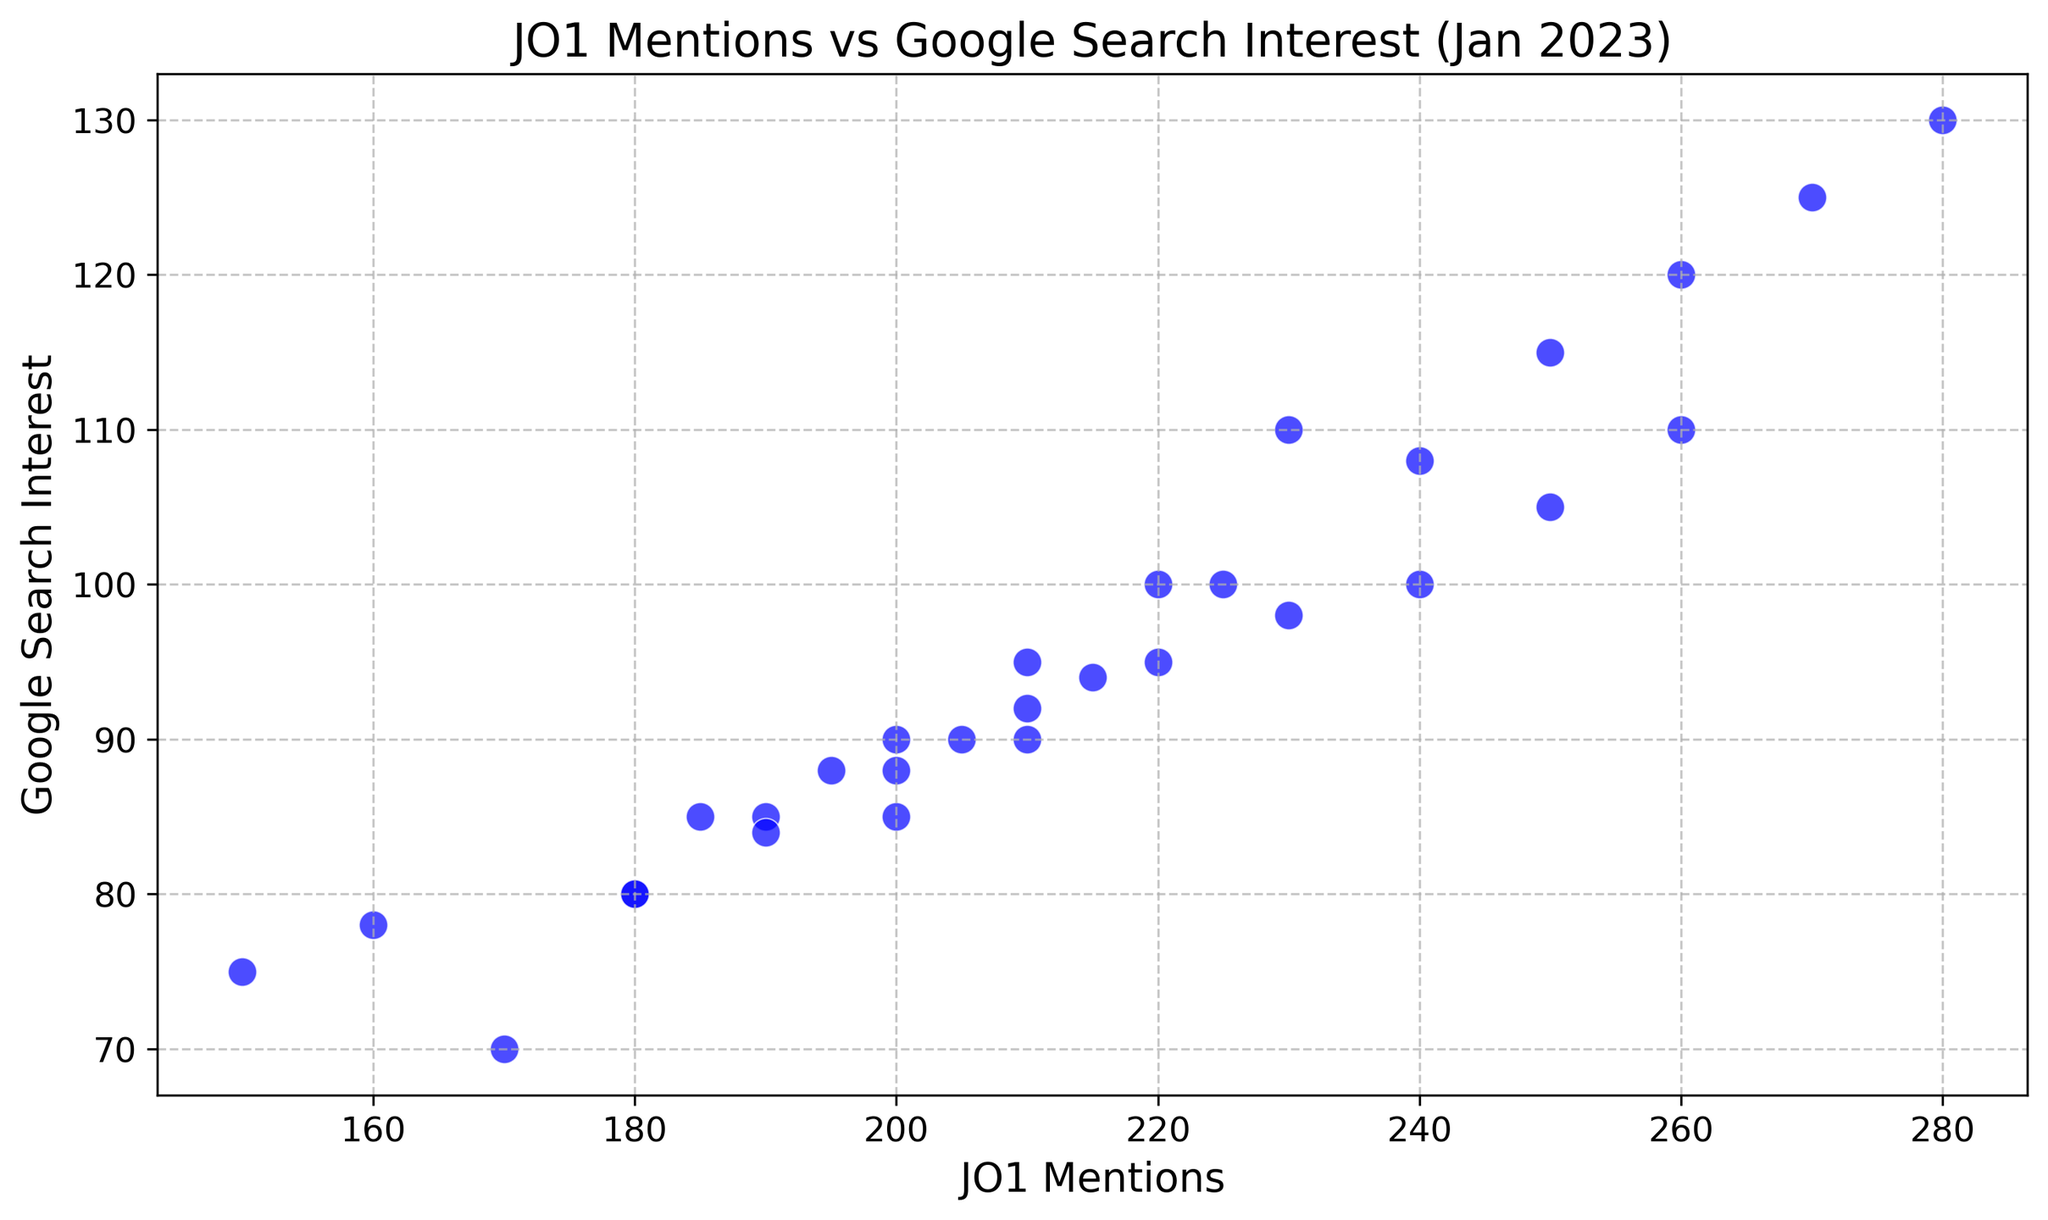Which point represents the maximum JO1 mentions, and what is the corresponding Google search interest? Identify the highest value on the x-axis (JO1 mentions); it's around 280. Trace this point up to the scatter point, which correlates to 130 on the y-axis (Google search interest).
Answer: 280 mentions, 130 interest On what date were JO1 mentions and Google search interest both at their highest? Referring to the maximum values identified in the previous question, find the corresponding date in the data; January 15th has 280 mentions and 130 interest.
Answer: January 15th What is the difference between the highest and lowest Google search interest? Identify the highest value of Google search interest (130) and the lowest (70). Subtract the lowest from the highest: 130 - 70.
Answer: 60 What is the average JO1 mentions for days when the Google search interest is 100 or above? Sum the JO1 mentions for dates when Google search interest is at least 100 (230, 250, 240, 260, 270, 280, 260, 250, 240, 230) and divide by the count of these entries (10). (230 + 250 + 240 + 260 + 270 + 280 + 260 + 250 + 240 + 230) / 10 = 250
Answer: 250 Which day had the lowest JO1 mentions, and what was the Google search interest on that day? Find the day with the minimum value on the x-axis (150 mentions). Trace this point up to the scatter point; it corresponds to 75 on the y-axis (Google search interest).
Answer: January 1st, 75 interest Is there a trend where higher JO1 mentions result in higher Google search interest? Observe the scatter plot for general trends: as you move to the right (increasing JO1 mentions), the points generally go upwards (increasing Google search interest).
Answer: Yes What is the span (range) of JO1 mentions in the data? Identify the highest and lowest values of JO1 mentions (280 and 150, respectively). Subtract the lowest from the highest: 280 - 150.
Answer: 130 Calculate the total JO1 mentions across all days. Sum all the values of JO1 mentions: 150 + 180 + 200 + 170 + 160 + 210 + 220 + 200 + 190 + 230 + 250 + 240 + 260 + 270 + 280 + 260 + 250 + 240 + 230 + 220 + 210 + 205 + 195 + 185 + 180 + 190 + 200 + 210 + 215 + 225 = 6370
Answer: 6370 Which range of JO1 mentions (200-230 or 240-270) shows a higher average Google search interest? Calculate average Google search interest for JO1 mentions between 200-230: (85 + 90 + 85 + 110 + 100 + 110 + 105 + 100 + 98) / 9 = 98.88. Calculate average Google search interest for mentions between 240-270: (115 + 120 + 125 + 130 + 110 + 105 + 100) / 7 = 115
Answer: 240-270 What is the median Google search interest? Arrange the Google search interest values in ascending order and find the middle value. The middle values are 85 and 88, so the median is (85 + 88) / 2 = 86.5
Answer: 86.5 